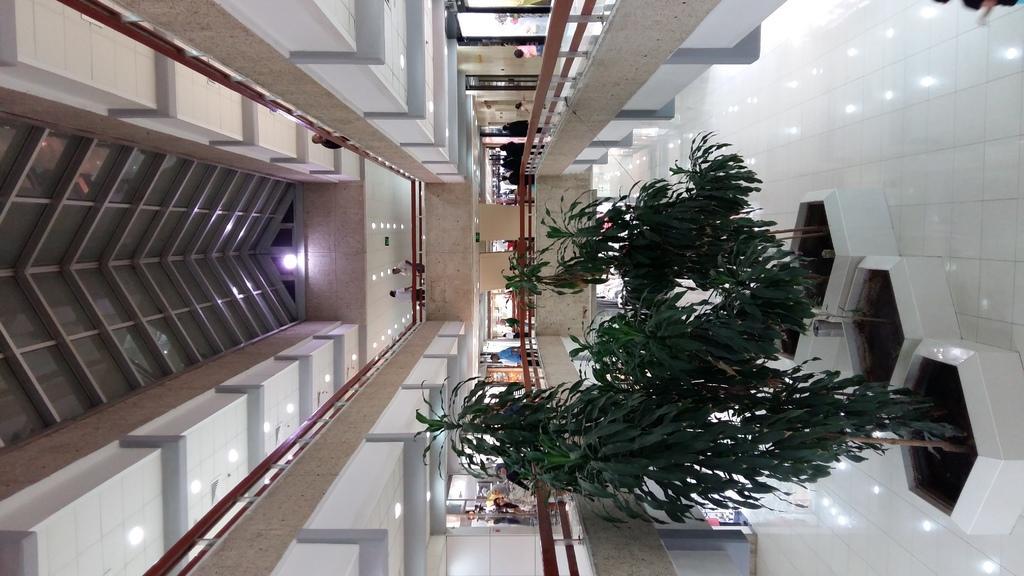Please provide a concise description of this image. This image is taken indoors. On the right side of the image there is a floor. At the top right of the image there is a person. In the middle of the image there are a few plants and trees in the pots. On the left side of the image there are many walls, railings and lights. There are a few stores and a few people are standing on the floor. There is a ceiling with a few lights. 